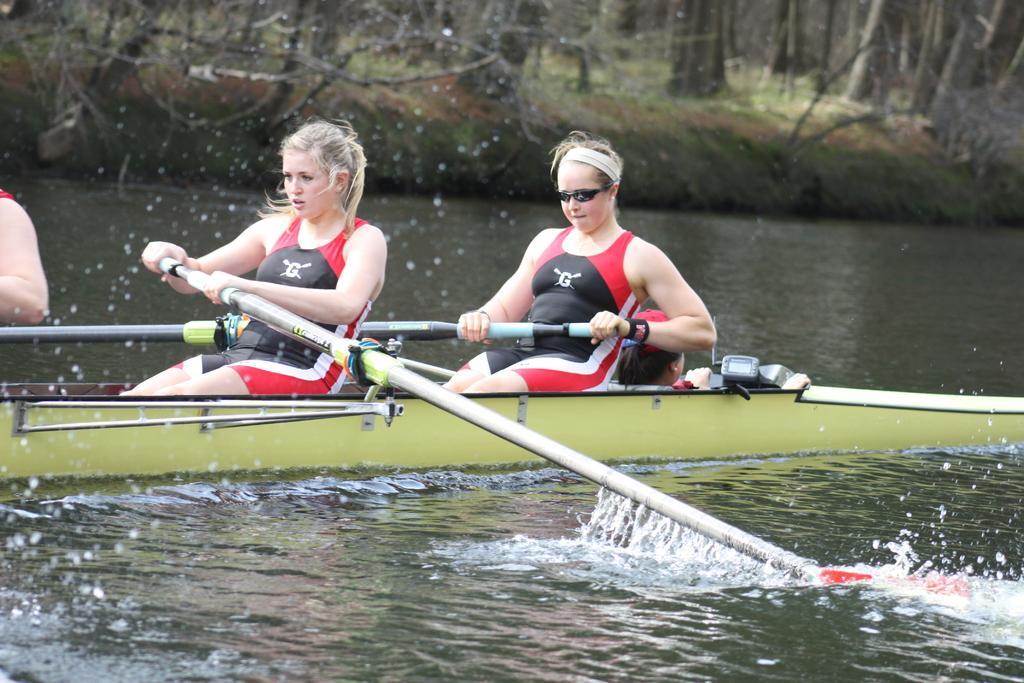How would you summarize this image in a sentence or two? In the picture we can see water and on it we can see a boat which is yellow in color with three persons sitting in it and riding it with a stick and behind them we can see a grass surface with dried plants and trees. 